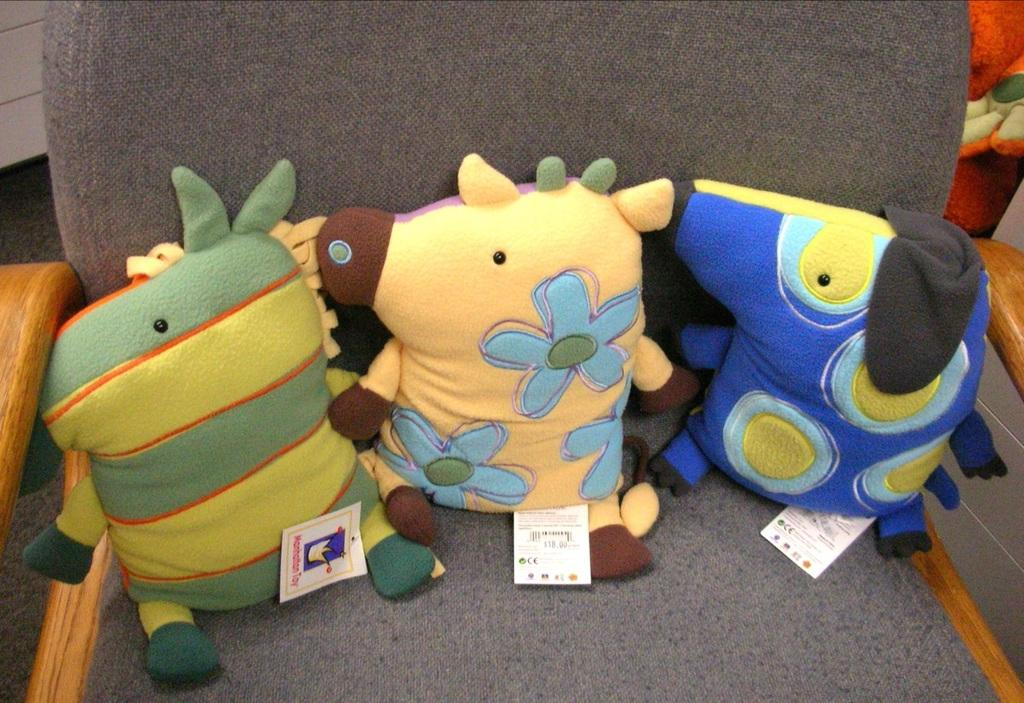What type of objects can be seen in the image? There are toys in the image. Where are the tags located in the image? The tags are on a chair in the image. Can you describe the orange object in the image? There is an orange object on the right side of the image. How many cats are coughing in the image? There are no cats present in the image, and therefore no one is coughing. 